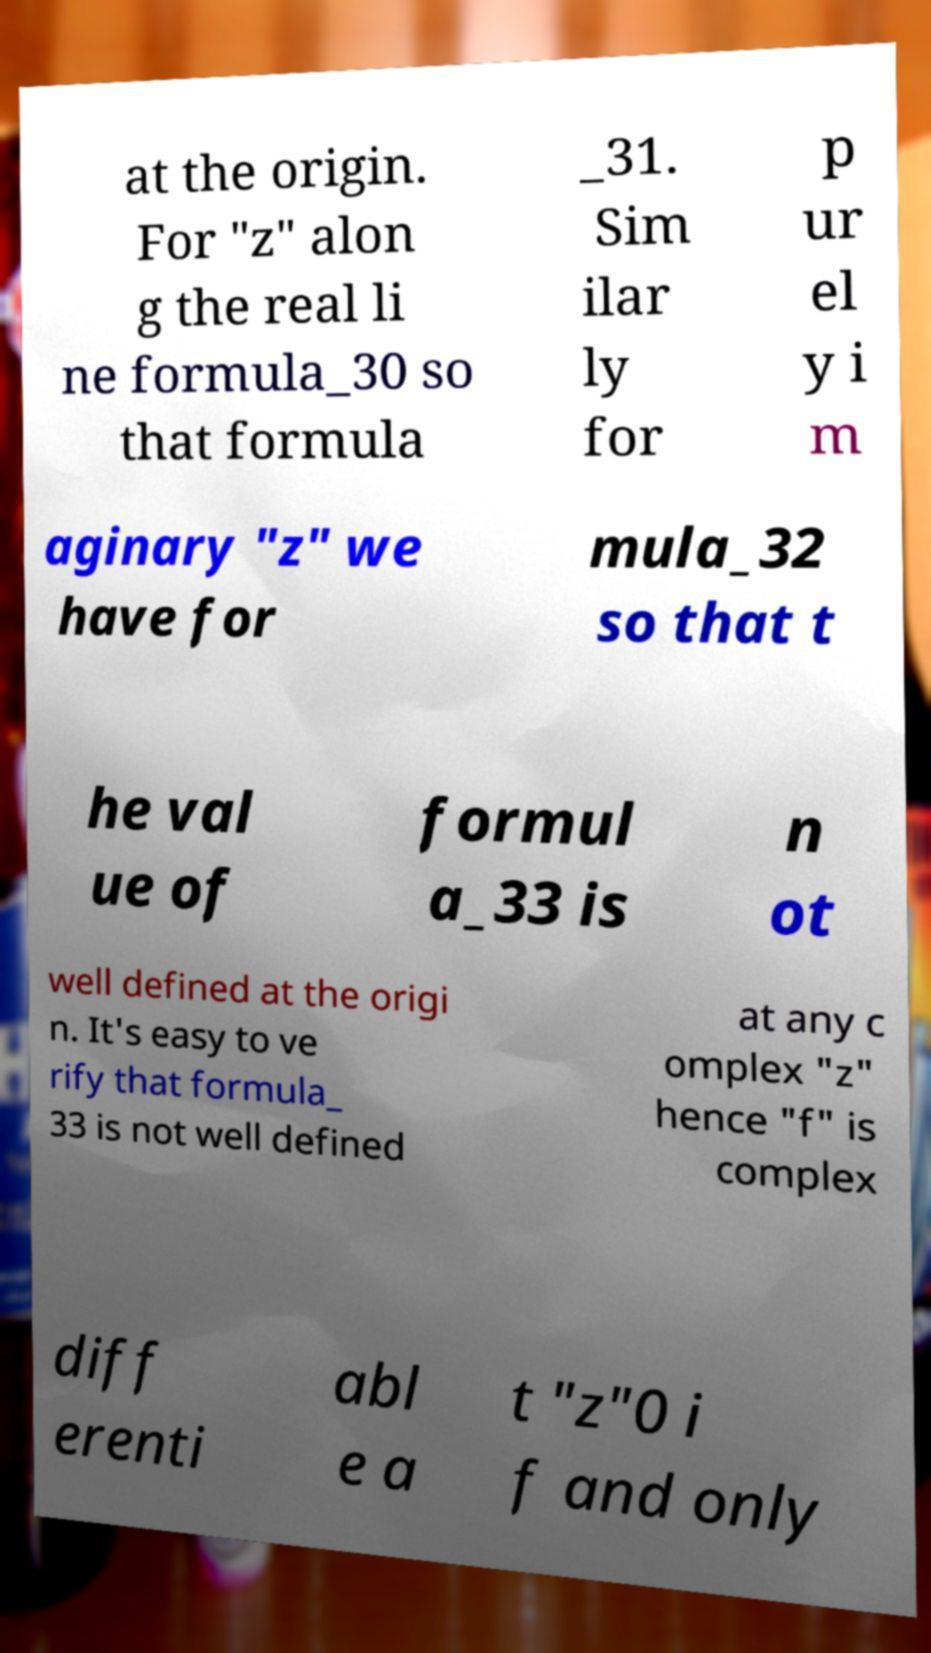Can you read and provide the text displayed in the image?This photo seems to have some interesting text. Can you extract and type it out for me? at the origin. For "z" alon g the real li ne formula_30 so that formula _31. Sim ilar ly for p ur el y i m aginary "z" we have for mula_32 so that t he val ue of formul a_33 is n ot well defined at the origi n. It's easy to ve rify that formula_ 33 is not well defined at any c omplex "z" hence "f" is complex diff erenti abl e a t "z"0 i f and only 